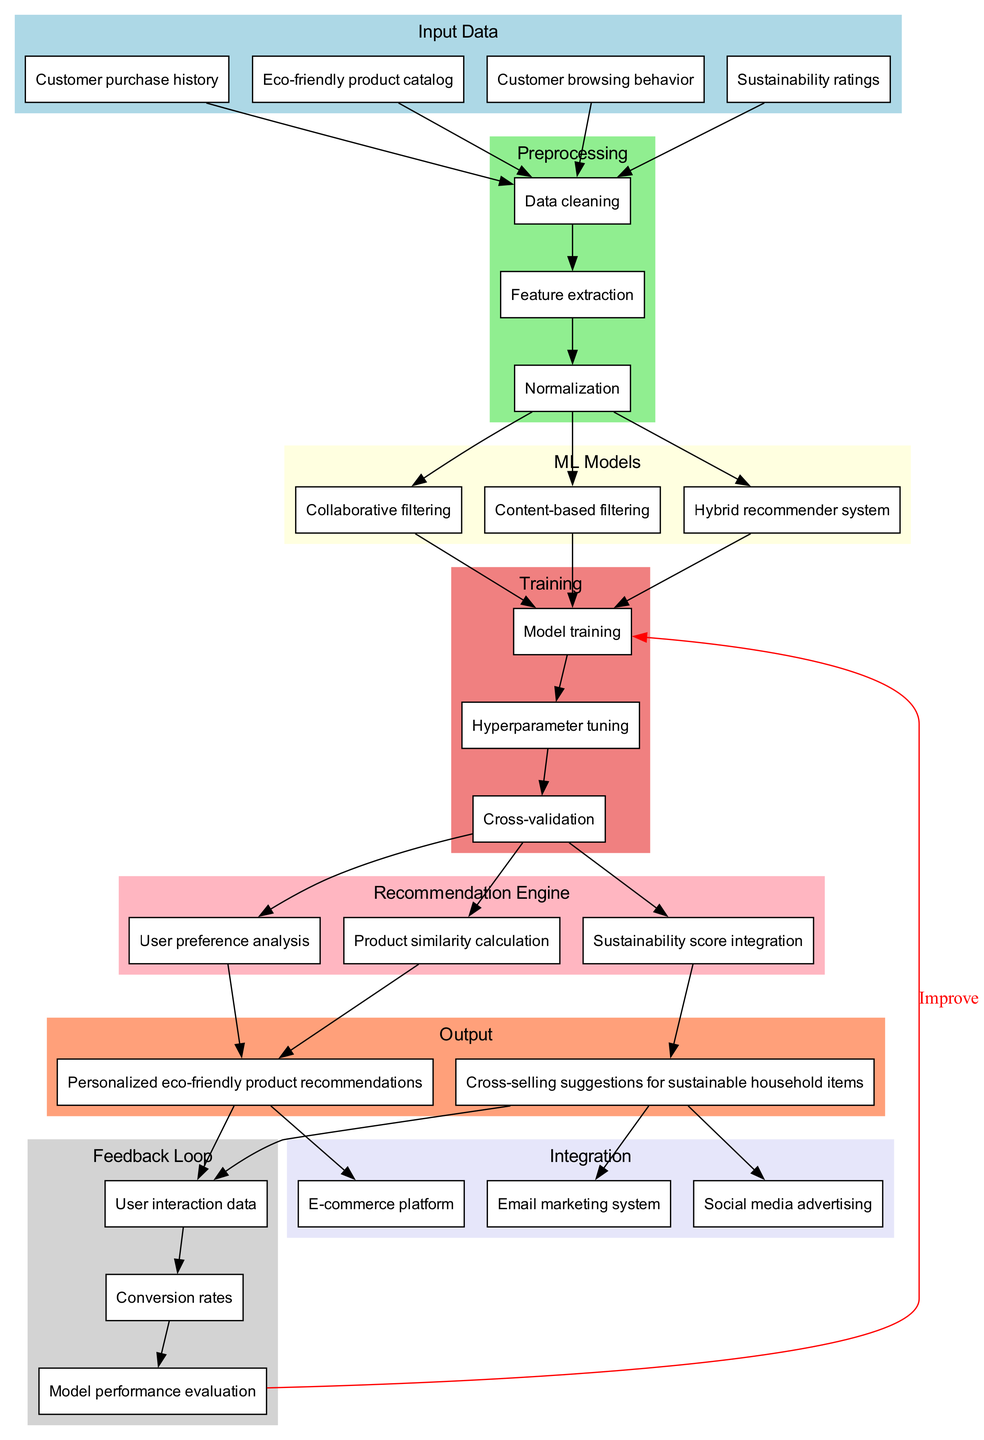What are the four types of input data in this diagram? The diagram lists four types of input data: "Customer purchase history", "Eco-friendly product catalog", "Customer browsing behavior", and "Sustainability ratings". These are presented in the Input Data cluster.
Answer: Customer purchase history, Eco-friendly product catalog, Customer browsing behavior, Sustainability ratings How many machine learning models are used in the recommendation system? The diagram indicates three different machine learning models: "Collaborative filtering", "Content-based filtering", and "Hybrid recommender system", which are grouped under ML Models.
Answer: Three What happens after data cleaning in the preprocessing stage? Following data cleaning, the next step indicated in the diagram is "Feature extraction", followed by "Normalization". This flow shows the sequential steps in the preprocessing stage.
Answer: Feature extraction What is the output of the recommendation engine based on user preference analysis? The diagram shows that "User preference analysis" leads to "Personalized eco-friendly product recommendations", directly indicating the output from that node.
Answer: Personalized eco-friendly product recommendations What is the feedback loop's role in the model improvement process? The feedback loop starts from "User interaction data" and goes to "Conversion rates", which then connects to "Model performance evaluation". From "Model performance evaluation", there is an edge labeled "Improve" back to "Model training", indicating this cycle is crucial for model enhancement.
Answer: Improve How does the recommendation engine integrate sustainability? The diagram highlights that "Sustainability score integration" is part of the recommendation engine, which suggests that sustainability metrics are incorporated into the recommendations provided to users.
Answer: Sustainability score integration Which integration method does the recommendation system use to promote cross-selling suggestions? The diagram explicitly shows that "Cross-selling suggestions for sustainable household items" are integrated with the "Email marketing system" and "Social media advertising". This indicates multiple avenues for cross-selling products.
Answer: Email marketing system, Social media advertising What crucial metric connects the feedback loop to model evaluation? The diagram illustrates that "Conversion rates" connect to "Model performance evaluation", which is a critical metric for measuring the effectiveness of the recommendation system.
Answer: Conversion rates 